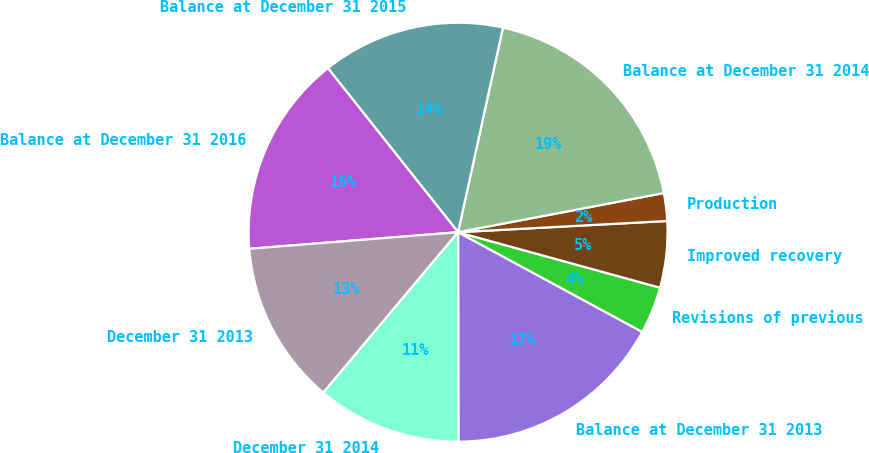Convert chart to OTSL. <chart><loc_0><loc_0><loc_500><loc_500><pie_chart><fcel>Balance at December 31 2013<fcel>Revisions of previous<fcel>Improved recovery<fcel>Production<fcel>Balance at December 31 2014<fcel>Balance at December 31 2015<fcel>Balance at December 31 2016<fcel>December 31 2013<fcel>December 31 2014<nl><fcel>17.08%<fcel>3.63%<fcel>5.12%<fcel>2.14%<fcel>18.57%<fcel>14.11%<fcel>15.59%<fcel>12.62%<fcel>11.14%<nl></chart> 